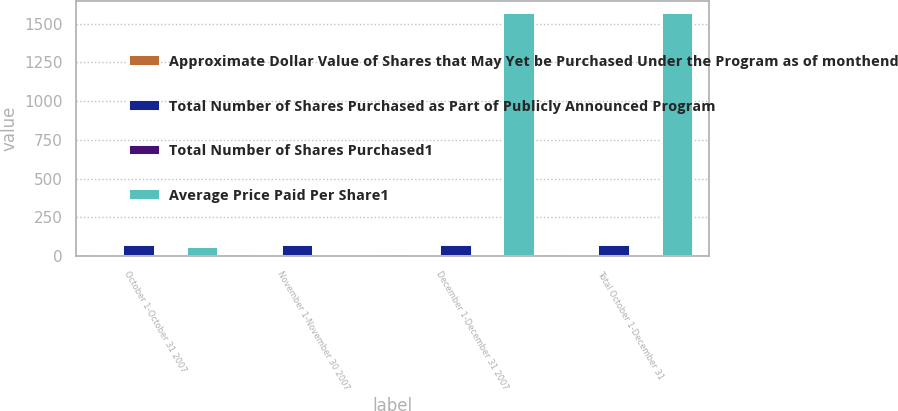Convert chart to OTSL. <chart><loc_0><loc_0><loc_500><loc_500><stacked_bar_chart><ecel><fcel>October 1-October 31 2007<fcel>November 1-November 30 2007<fcel>December 1-December 31 2007<fcel>Total October 1-December 31<nl><fcel>Approximate Dollar Value of Shares that May Yet be Purchased Under the Program as of monthend<fcel>2.1<fcel>3.8<fcel>2.2<fcel>8.1<nl><fcel>Total Number of Shares Purchased as Part of Publicly Announced Program<fcel>75.58<fcel>72.19<fcel>73.04<fcel>73.31<nl><fcel>Total Number of Shares Purchased1<fcel>2.1<fcel>3.8<fcel>2.2<fcel>8.1<nl><fcel>Average Price Paid Per Share1<fcel>60<fcel>8.1<fcel>1566<fcel>1566<nl></chart> 